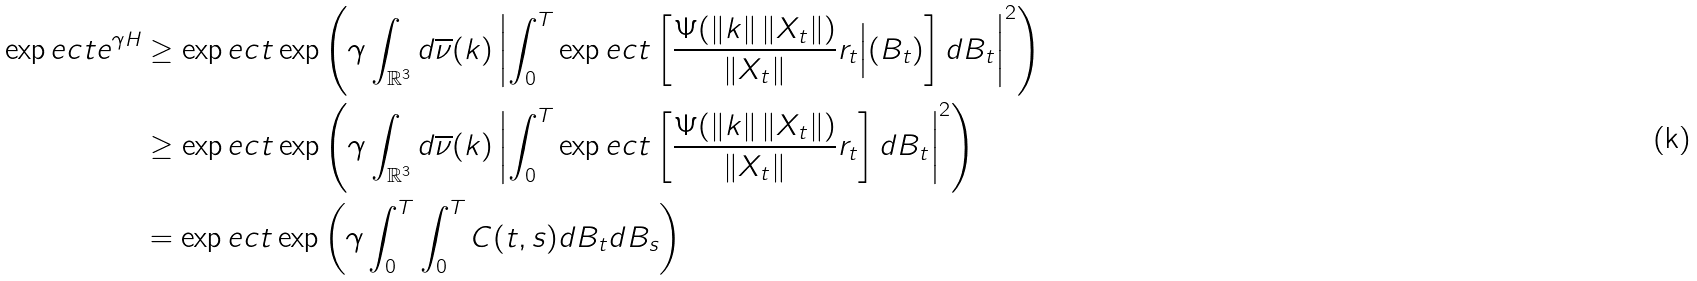Convert formula to latex. <formula><loc_0><loc_0><loc_500><loc_500>\exp e c t e ^ { \gamma H } & \geq \exp e c t \exp \left ( \gamma \int _ { \mathbb { R } ^ { 3 } } d \overline { \nu } ( k ) \left | \int _ { 0 } ^ { T } \exp e c t \left [ \frac { \Psi ( \| k \| \, \| X _ { t } \| ) } { \| X _ { t } \| } r _ { t } \Big | ( B _ { t } ) \right ] d B _ { t } \right | ^ { 2 } \right ) \\ & \geq \exp e c t \exp \left ( \gamma \int _ { \mathbb { R } ^ { 3 } } d \overline { \nu } ( k ) \left | \int _ { 0 } ^ { T } \exp e c t \left [ \frac { \Psi ( \| k \| \, \| X _ { t } \| ) } { \| X _ { t } \| } r _ { t } \right ] d B _ { t } \right | ^ { 2 } \right ) \\ & = \exp e c t \exp \left ( \gamma \int _ { 0 } ^ { T } \int _ { 0 } ^ { T } C ( t , s ) d B _ { t } d B _ { s } \right ) \\</formula> 